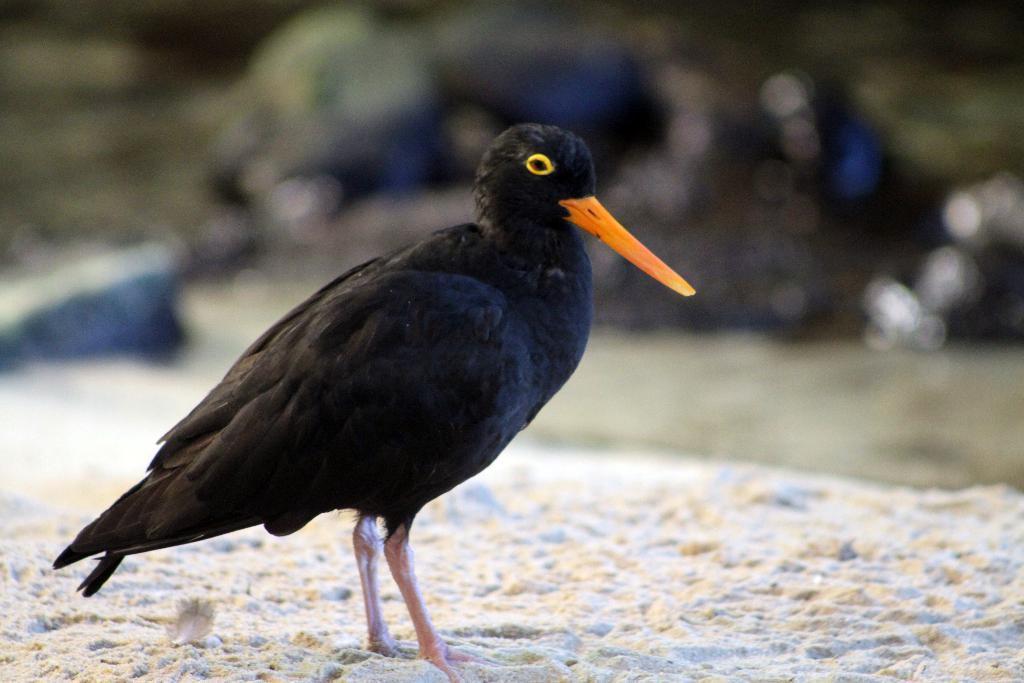In one or two sentences, can you explain what this image depicts? In this picture I can observe black color bird in the middle of the picture. The background is blurred. 